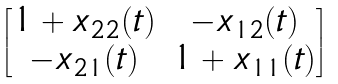Convert formula to latex. <formula><loc_0><loc_0><loc_500><loc_500>\begin{bmatrix} 1 + x _ { 2 2 } ( t ) & - x _ { 1 2 } ( t ) \\ - x _ { 2 1 } ( t ) & 1 + x _ { 1 1 } ( t ) \end{bmatrix}</formula> 